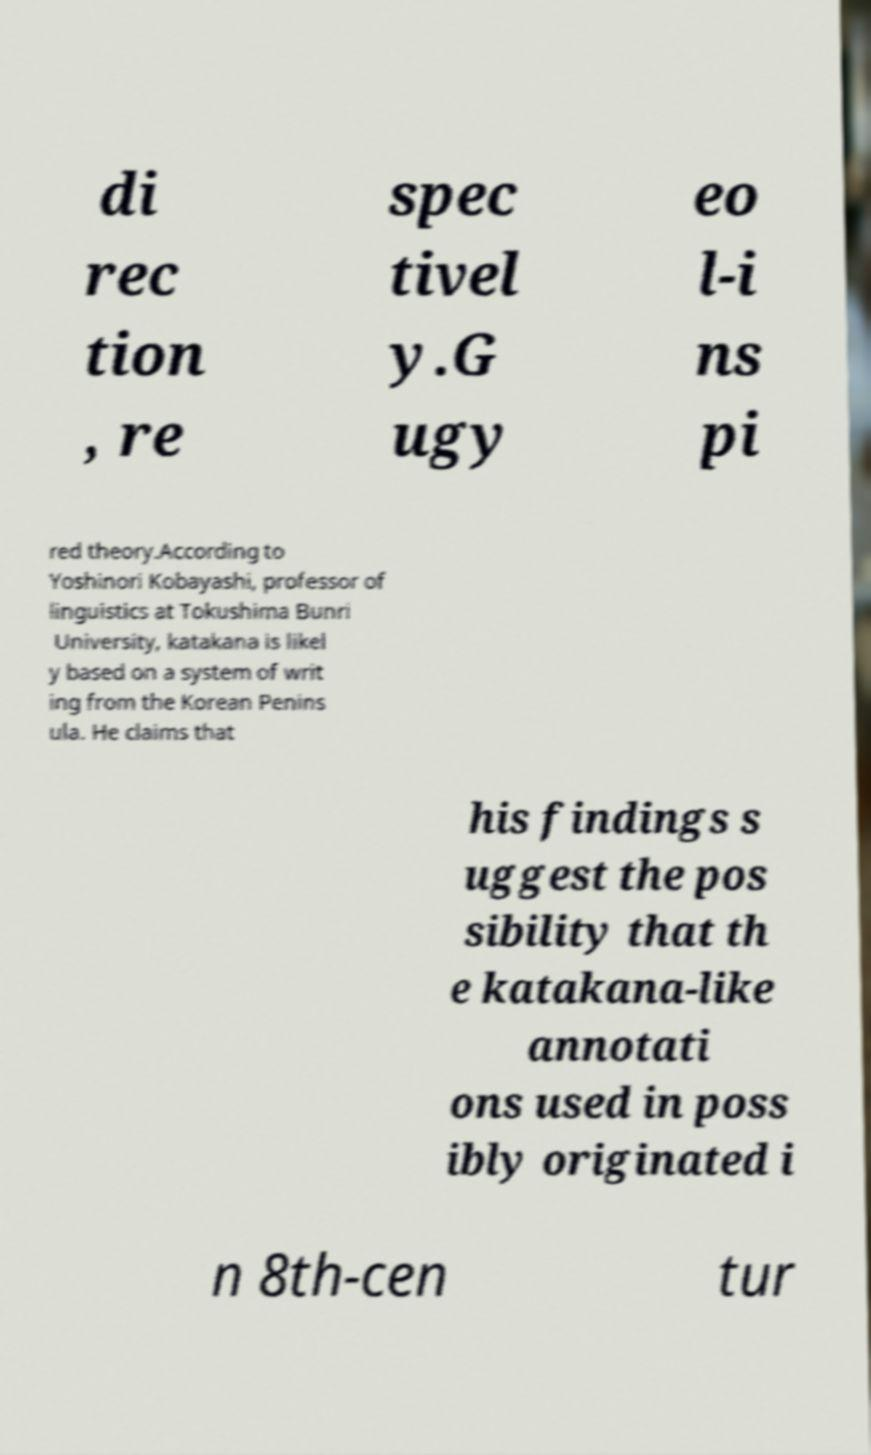Can you accurately transcribe the text from the provided image for me? di rec tion , re spec tivel y.G ugy eo l-i ns pi red theory.According to Yoshinori Kobayashi, professor of linguistics at Tokushima Bunri University, katakana is likel y based on a system of writ ing from the Korean Penins ula. He claims that his findings s uggest the pos sibility that th e katakana-like annotati ons used in poss ibly originated i n 8th-cen tur 